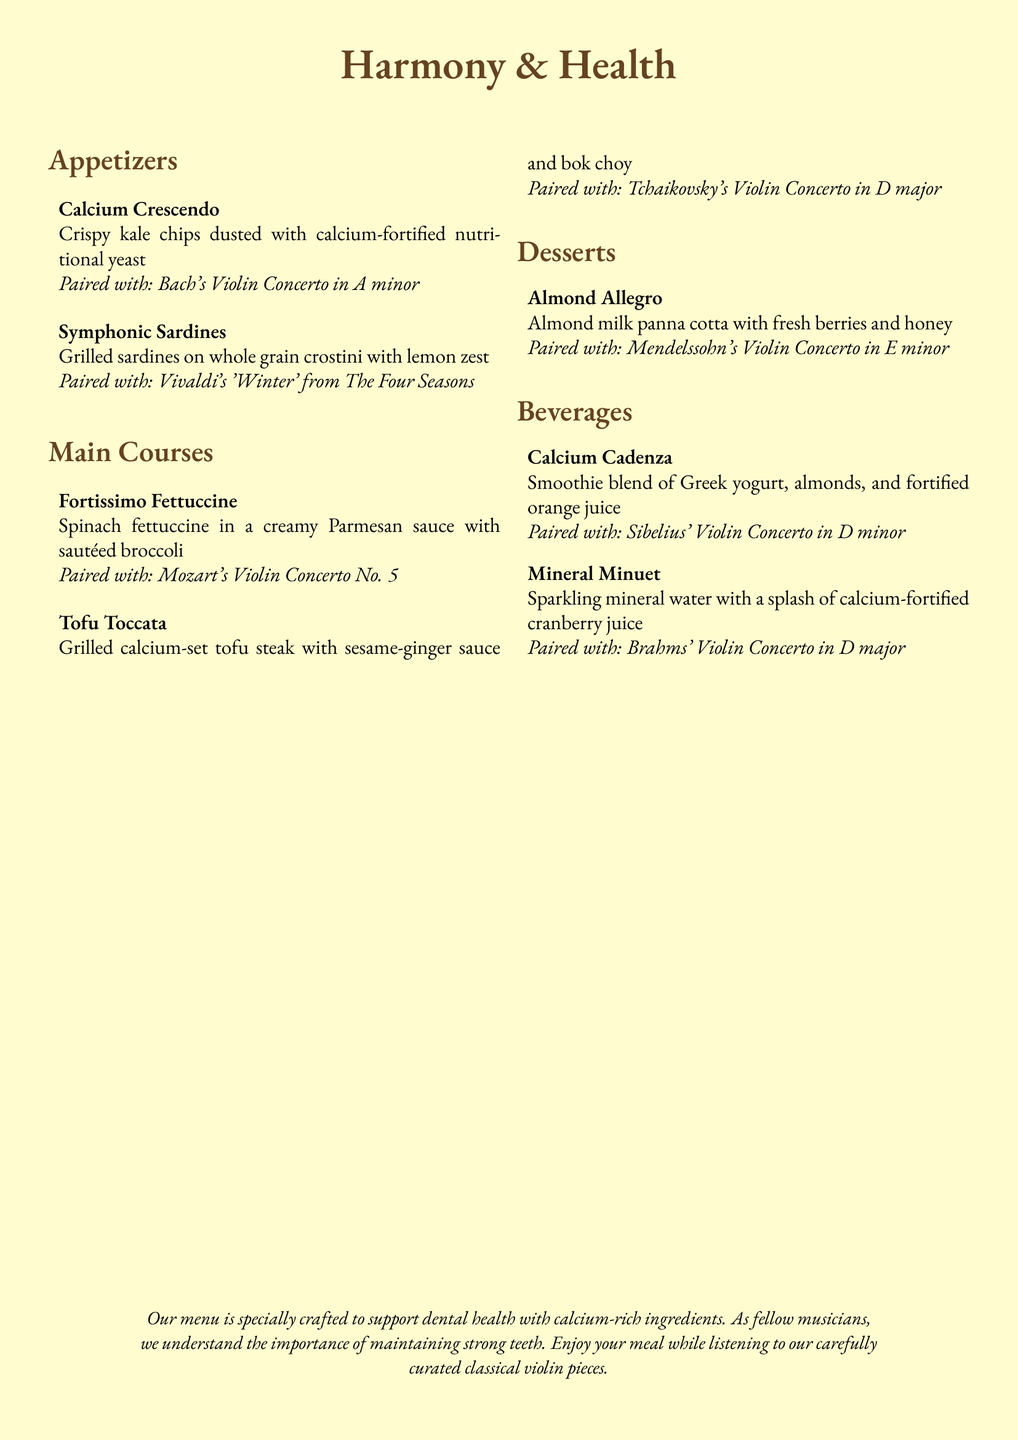What are the appetizers listed on the menu? The appetizers are mentioned in the "Appetizers" section under the title "Harmony & Health".
Answer: Calcium Crescendo, Symphonic Sardines What classical piece is paired with the Tofu Toccata? The pairing for Tofu Toccata is found in the description of that dish.
Answer: Tchaikovsky's Violin Concerto in D major How many desserts are included in the menu? The total number of desserts can be calculated by counting the items listed in the "Desserts" section.
Answer: 1 What beverage includes Greek yogurt? The mention of Greek yogurt is found in the "Beverages" section where specific drinks are described.
Answer: Calcium Cadenza Which main course features spinach? The main courses section includes descriptions to identify which dish contains spinach.
Answer: Fortissimo Fettuccine What is the color scheme of the menu? The colors are implied in the document's formatting, describing the main color for headings and background.
Answer: Violin brown and cream color 